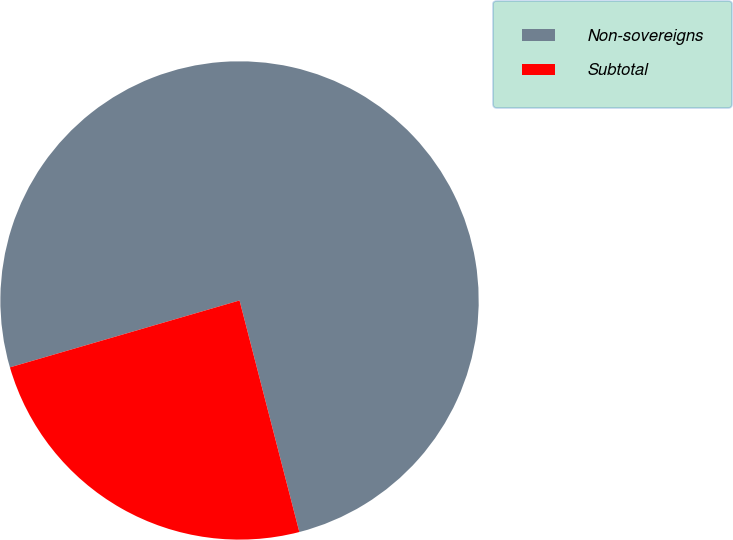Convert chart to OTSL. <chart><loc_0><loc_0><loc_500><loc_500><pie_chart><fcel>Non-sovereigns<fcel>Subtotal<nl><fcel>75.49%<fcel>24.51%<nl></chart> 